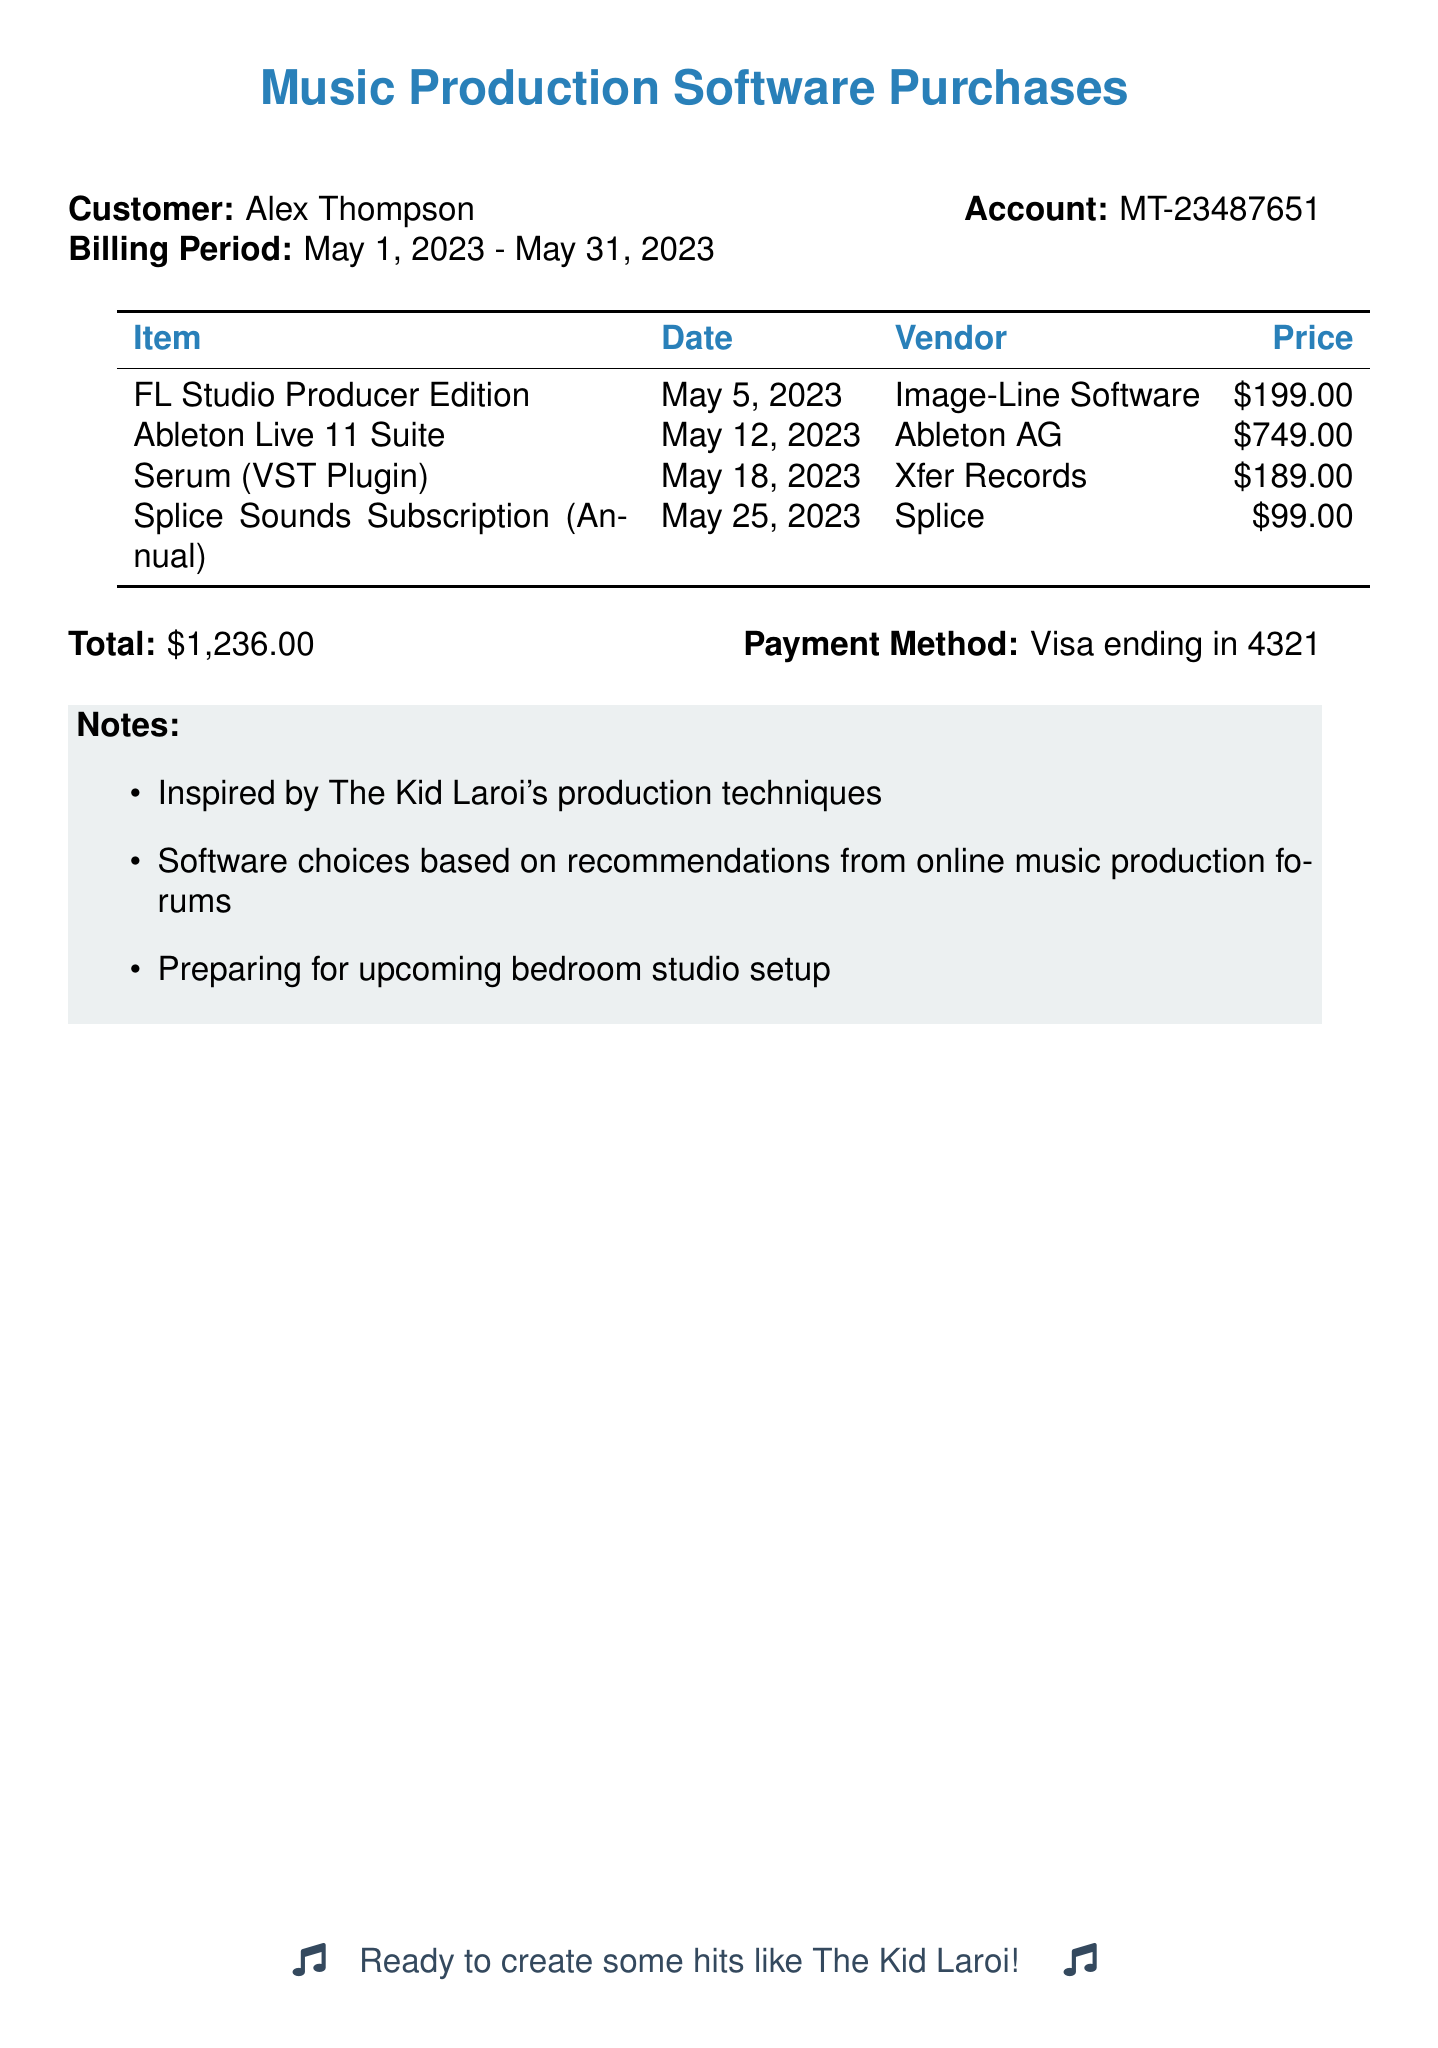What is the customer's name? The customer's name is provided in the document as Alex Thompson.
Answer: Alex Thompson What was purchased on May 12, 2023? The item purchased on this date is listed in the table as Ableton Live 11 Suite.
Answer: Ableton Live 11 Suite How much did the Serum VST Plugin cost? The cost for Serum (VST Plugin) is specified in the document as $189.00.
Answer: $189.00 What is the total amount spent? The total amount is calculated as the sum of all items listed in the table, which equals $1,236.00.
Answer: $1,236.00 Who is the vendor for FL Studio? The vendor is stated in the document as Image-Line Software.
Answer: Image-Line Software Why were the software choices made? The document includes notes indicating choices were based on recommendations from online music production forums.
Answer: Recommendations from online music production forums What payment method was used? The document specifies the payment method as Visa ending in 4321.
Answer: Visa ending in 4321 What date was the Splice Sounds subscription purchased? The date of purchase for Splice Sounds Subscription is provided as May 25, 2023.
Answer: May 25, 2023 What type of music production setup is being prepared for? The notes in the document indicate preparation for a bedroom studio setup.
Answer: Bedroom studio setup 